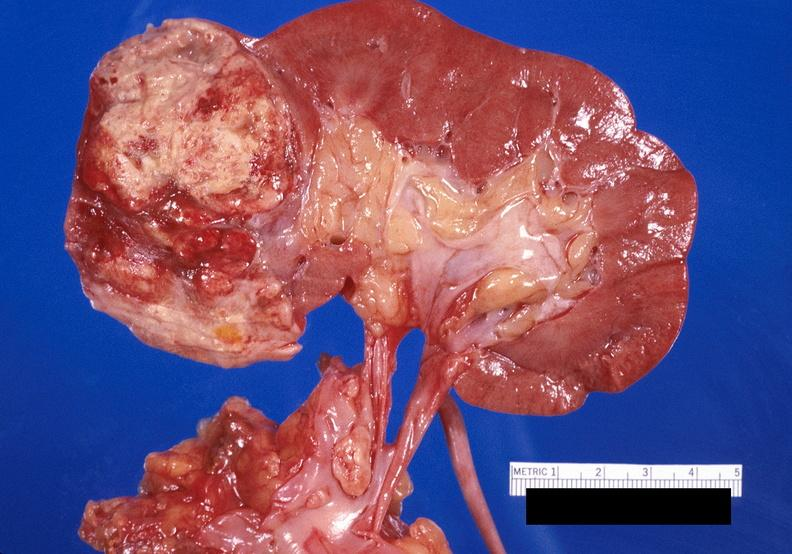where is this?
Answer the question using a single word or phrase. Urinary 